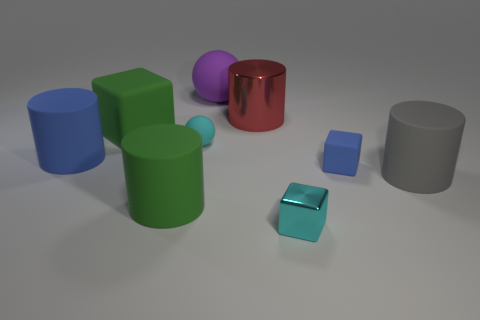What size is the green cylinder?
Offer a terse response. Large. Are there fewer large matte objects on the left side of the large purple matte ball than objects?
Ensure brevity in your answer.  Yes. Is the purple rubber ball the same size as the cyan metal thing?
Your response must be concise. No. There is a small object that is made of the same material as the tiny ball; what is its color?
Give a very brief answer. Blue. Is the number of green rubber objects that are right of the tiny blue rubber object less than the number of blue rubber objects right of the big metallic cylinder?
Your answer should be compact. Yes. How many objects have the same color as the big block?
Make the answer very short. 1. There is a large thing that is the same color as the big block; what is it made of?
Offer a terse response. Rubber. What number of matte objects are both to the left of the big gray object and to the right of the small cyan metal cube?
Keep it short and to the point. 1. The small cyan thing that is behind the shiny object that is in front of the large green matte block is made of what material?
Offer a very short reply. Rubber. Are there any tiny green balls made of the same material as the tiny blue thing?
Give a very brief answer. No. 